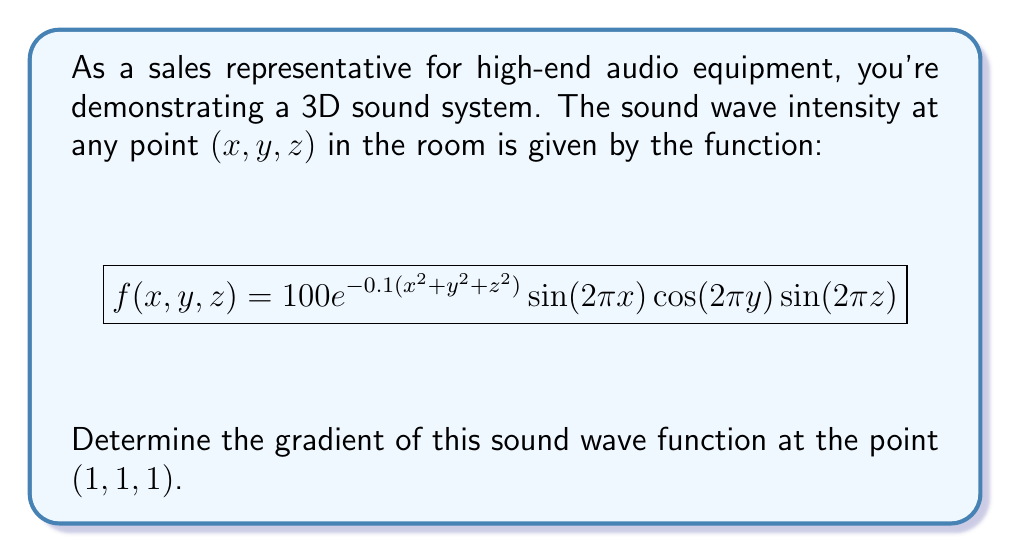Show me your answer to this math problem. To find the gradient of the sound wave function, we need to calculate the partial derivatives with respect to x, y, and z, and then evaluate them at the point (1,1,1).

Step 1: Calculate $\frac{\partial f}{\partial x}$
$$\begin{align}
\frac{\partial f}{\partial x} &= 100e^{-0.1(x^2+y^2+z^2)} [-0.2x \sin(2\pi x) \cos(2\pi y) \sin(2\pi z) + 2\pi \cos(2\pi x) \cos(2\pi y) \sin(2\pi z)]
\end{align}$$

Step 2: Calculate $\frac{\partial f}{\partial y}$
$$\begin{align}
\frac{\partial f}{\partial y} &= 100e^{-0.1(x^2+y^2+z^2)} [-0.2y \sin(2\pi x) \cos(2\pi y) \sin(2\pi z) - 2\pi \sin(2\pi x) \sin(2\pi y) \sin(2\pi z)]
\end{align}$$

Step 3: Calculate $\frac{\partial f}{\partial z}$
$$\begin{align}
\frac{\partial f}{\partial z} &= 100e^{-0.1(x^2+y^2+z^2)} [-0.2z \sin(2\pi x) \cos(2\pi y) \sin(2\pi z) + 2\pi \sin(2\pi x) \cos(2\pi y) \cos(2\pi z)]
\end{align}$$

Step 4: Evaluate the partial derivatives at the point (1,1,1)
$$\begin{align}
\frac{\partial f}{\partial x}|_{(1,1,1)} &= 100e^{-0.3} [-0.2 \sin(2\pi) \cos(2\pi) \sin(2\pi) + 2\pi \cos(2\pi) \cos(2\pi) \sin(2\pi)] = 0 \\
\frac{\partial f}{\partial y}|_{(1,1,1)} &= 100e^{-0.3} [-0.2 \sin(2\pi) \cos(2\pi) \sin(2\pi) - 2\pi \sin(2\pi) \sin(2\pi) \sin(2\pi)] = 0 \\
\frac{\partial f}{\partial z}|_{(1,1,1)} &= 100e^{-0.3} [-0.2 \sin(2\pi) \cos(2\pi) \sin(2\pi) + 2\pi \sin(2\pi) \cos(2\pi) \cos(2\pi)] = 0
\end{align}$$

Step 5: Form the gradient vector
$$\nabla f(1,1,1) = \left(\frac{\partial f}{\partial x}, \frac{\partial f}{\partial y}, \frac{\partial f}{\partial z}\right)_{(1,1,1)} = (0, 0, 0)$$
Answer: $(0, 0, 0)$ 